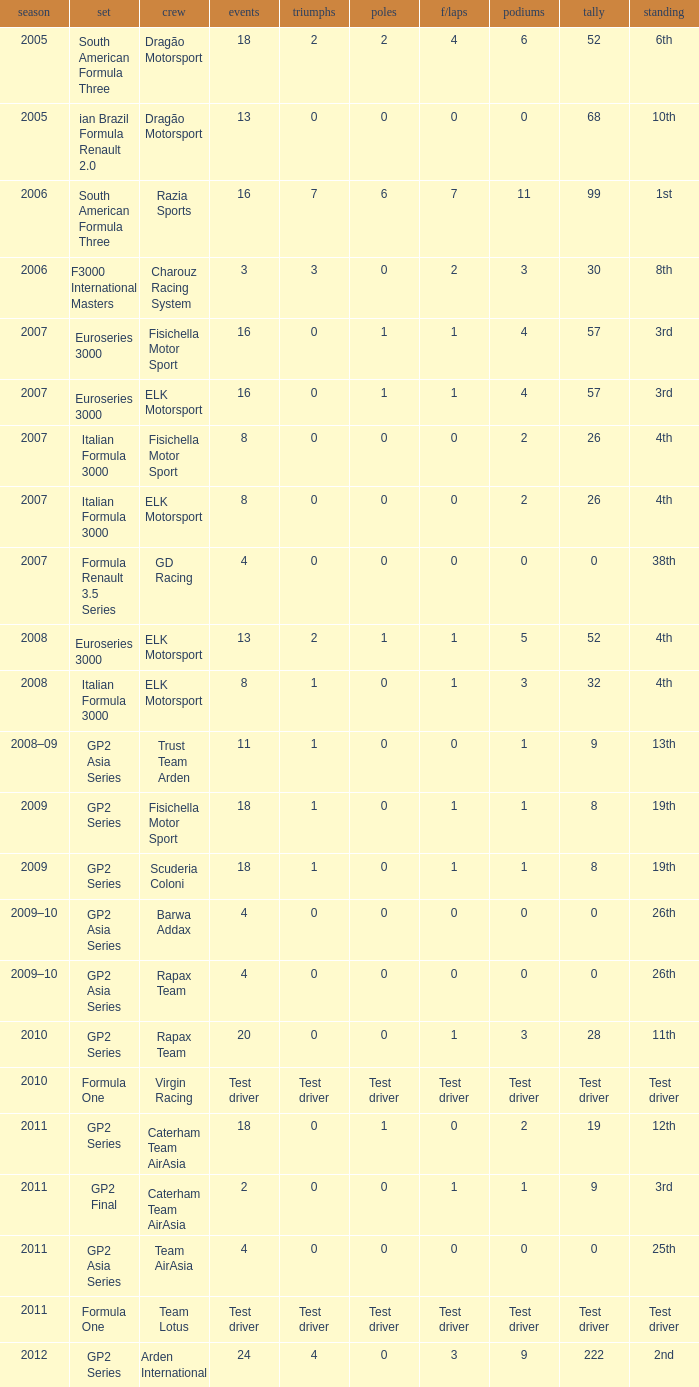How many races did he do in the year he had 8 points? 18, 18. 